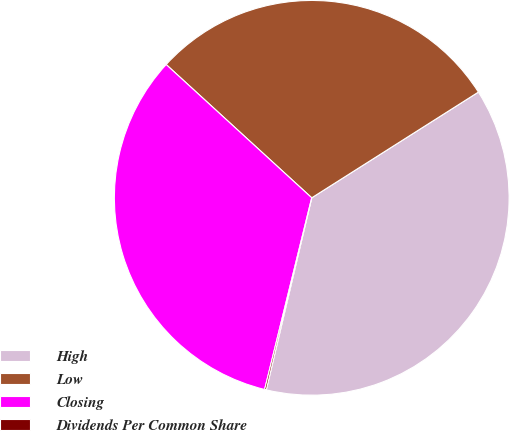Convert chart to OTSL. <chart><loc_0><loc_0><loc_500><loc_500><pie_chart><fcel>High<fcel>Low<fcel>Closing<fcel>Dividends Per Common Share<nl><fcel>37.69%<fcel>29.2%<fcel>32.96%<fcel>0.14%<nl></chart> 